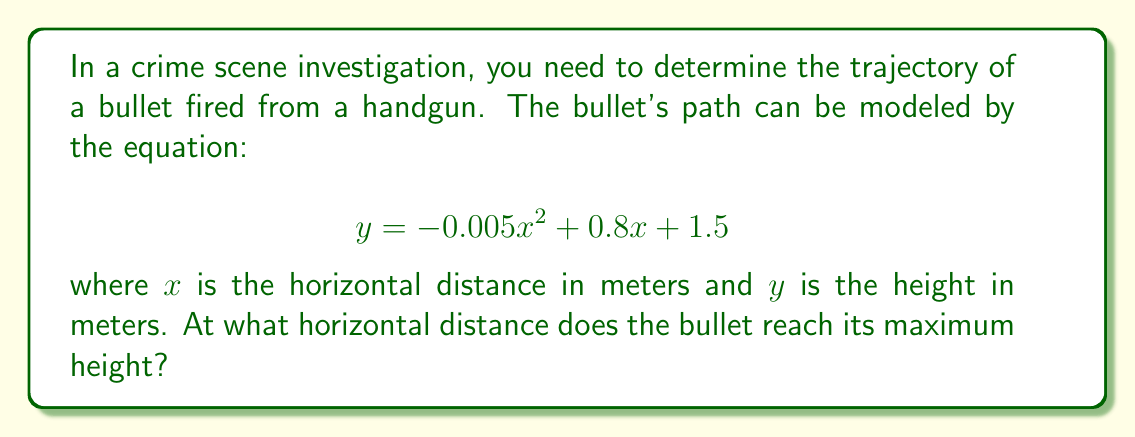What is the answer to this math problem? To find the maximum height of the bullet's trajectory, we need to determine the vertex of the parabola described by the given equation. The general form of a quadratic equation is:

$$y = ax^2 + bx + c$$

In our case, $a = -0.005$, $b = 0.8$, and $c = 1.5$.

For a quadratic equation, the x-coordinate of the vertex is given by the formula:

$$x = -\frac{b}{2a}$$

Substituting our values:

$$x = -\frac{0.8}{2(-0.005)} = -\frac{0.8}{-0.01} = 80$$

Therefore, the bullet reaches its maximum height at a horizontal distance of 80 meters.

To verify this result, we can also use calculus. The derivative of the function with respect to x is:

$$\frac{dy}{dx} = -0.01x + 0.8$$

Setting this equal to zero (to find the critical point):

$$-0.01x + 0.8 = 0$$
$$-0.01x = -0.8$$
$$x = 80$$

This confirms our previous calculation.
Answer: The bullet reaches its maximum height at a horizontal distance of 80 meters. 